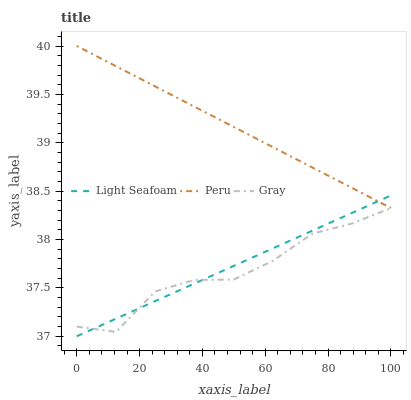Does Gray have the minimum area under the curve?
Answer yes or no. Yes. Does Peru have the maximum area under the curve?
Answer yes or no. Yes. Does Light Seafoam have the minimum area under the curve?
Answer yes or no. No. Does Light Seafoam have the maximum area under the curve?
Answer yes or no. No. Is Peru the smoothest?
Answer yes or no. Yes. Is Gray the roughest?
Answer yes or no. Yes. Is Light Seafoam the smoothest?
Answer yes or no. No. Is Light Seafoam the roughest?
Answer yes or no. No. Does Light Seafoam have the lowest value?
Answer yes or no. Yes. Does Peru have the lowest value?
Answer yes or no. No. Does Peru have the highest value?
Answer yes or no. Yes. Does Light Seafoam have the highest value?
Answer yes or no. No. Is Gray less than Peru?
Answer yes or no. Yes. Is Peru greater than Gray?
Answer yes or no. Yes. Does Light Seafoam intersect Peru?
Answer yes or no. Yes. Is Light Seafoam less than Peru?
Answer yes or no. No. Is Light Seafoam greater than Peru?
Answer yes or no. No. Does Gray intersect Peru?
Answer yes or no. No. 